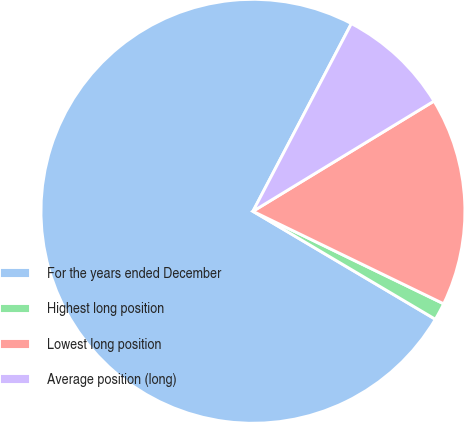<chart> <loc_0><loc_0><loc_500><loc_500><pie_chart><fcel>For the years ended December<fcel>Highest long position<fcel>Lowest long position<fcel>Average position (long)<nl><fcel>74.18%<fcel>1.32%<fcel>15.89%<fcel>8.61%<nl></chart> 